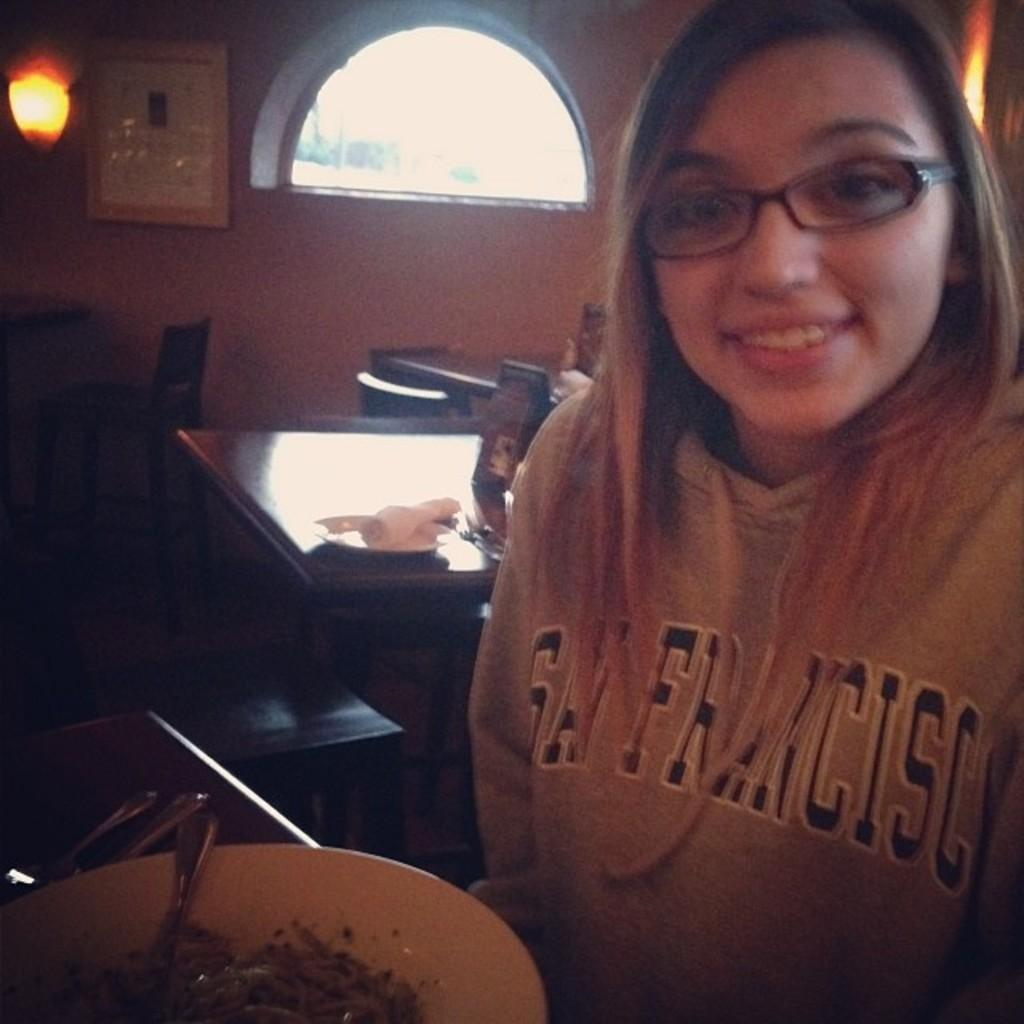What is the person in the image holding? The person is holding a plate. What is on the plate that the person is holding? There is a spoon and food on the plate. What type of furniture can be seen in the image? There are tables and chairs in the image. What is the background of the image? There is a wall and a window in the image. How many cats are sitting on the table in the image? There are no cats present in the image. What finger is the person using to eat the food on the plate? The image does not show the person's fingers, so it cannot be determined which finger they might be using to eat the food. 